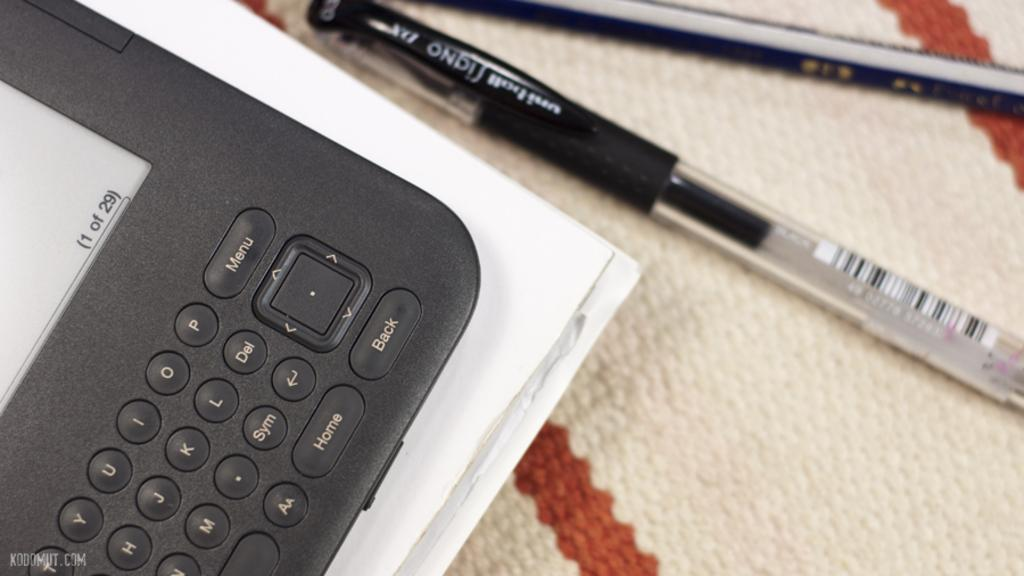<image>
Render a clear and concise summary of the photo. a small electronic device that says 'home' on one of the buttons 